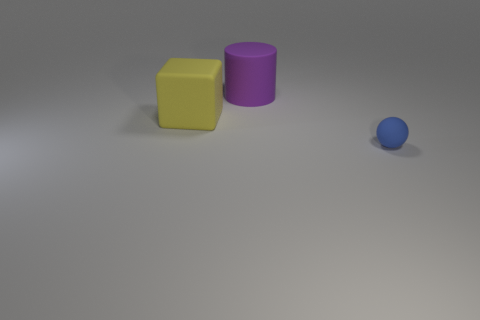Add 1 big cyan shiny cubes. How many objects exist? 4 Subtract all cylinders. How many objects are left? 2 Subtract all yellow cylinders. Subtract all blue matte spheres. How many objects are left? 2 Add 1 blue spheres. How many blue spheres are left? 2 Add 1 small gray spheres. How many small gray spheres exist? 1 Subtract 0 yellow cylinders. How many objects are left? 3 